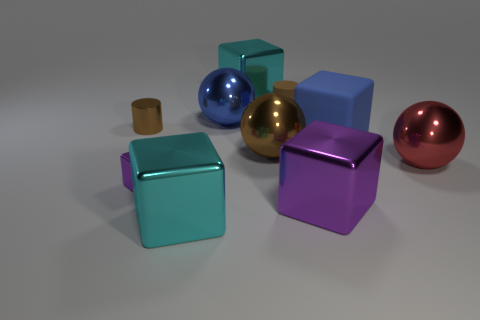How would you classify the objects in terms of real-world materials? The objects in the image can be classified by their visual characteristics akin to real-world materials. The spheres seem to be metal, as indicated by their highly reflective surfaces, while the cylinder is suggestive of rubber due to its matte texture. The cubes could be made of a form of plastic or painted wood, indicated by their solid colors and non-reflective surfaces. These materials are commonly used in various products due to their physical properties and ease of manufacturing. 